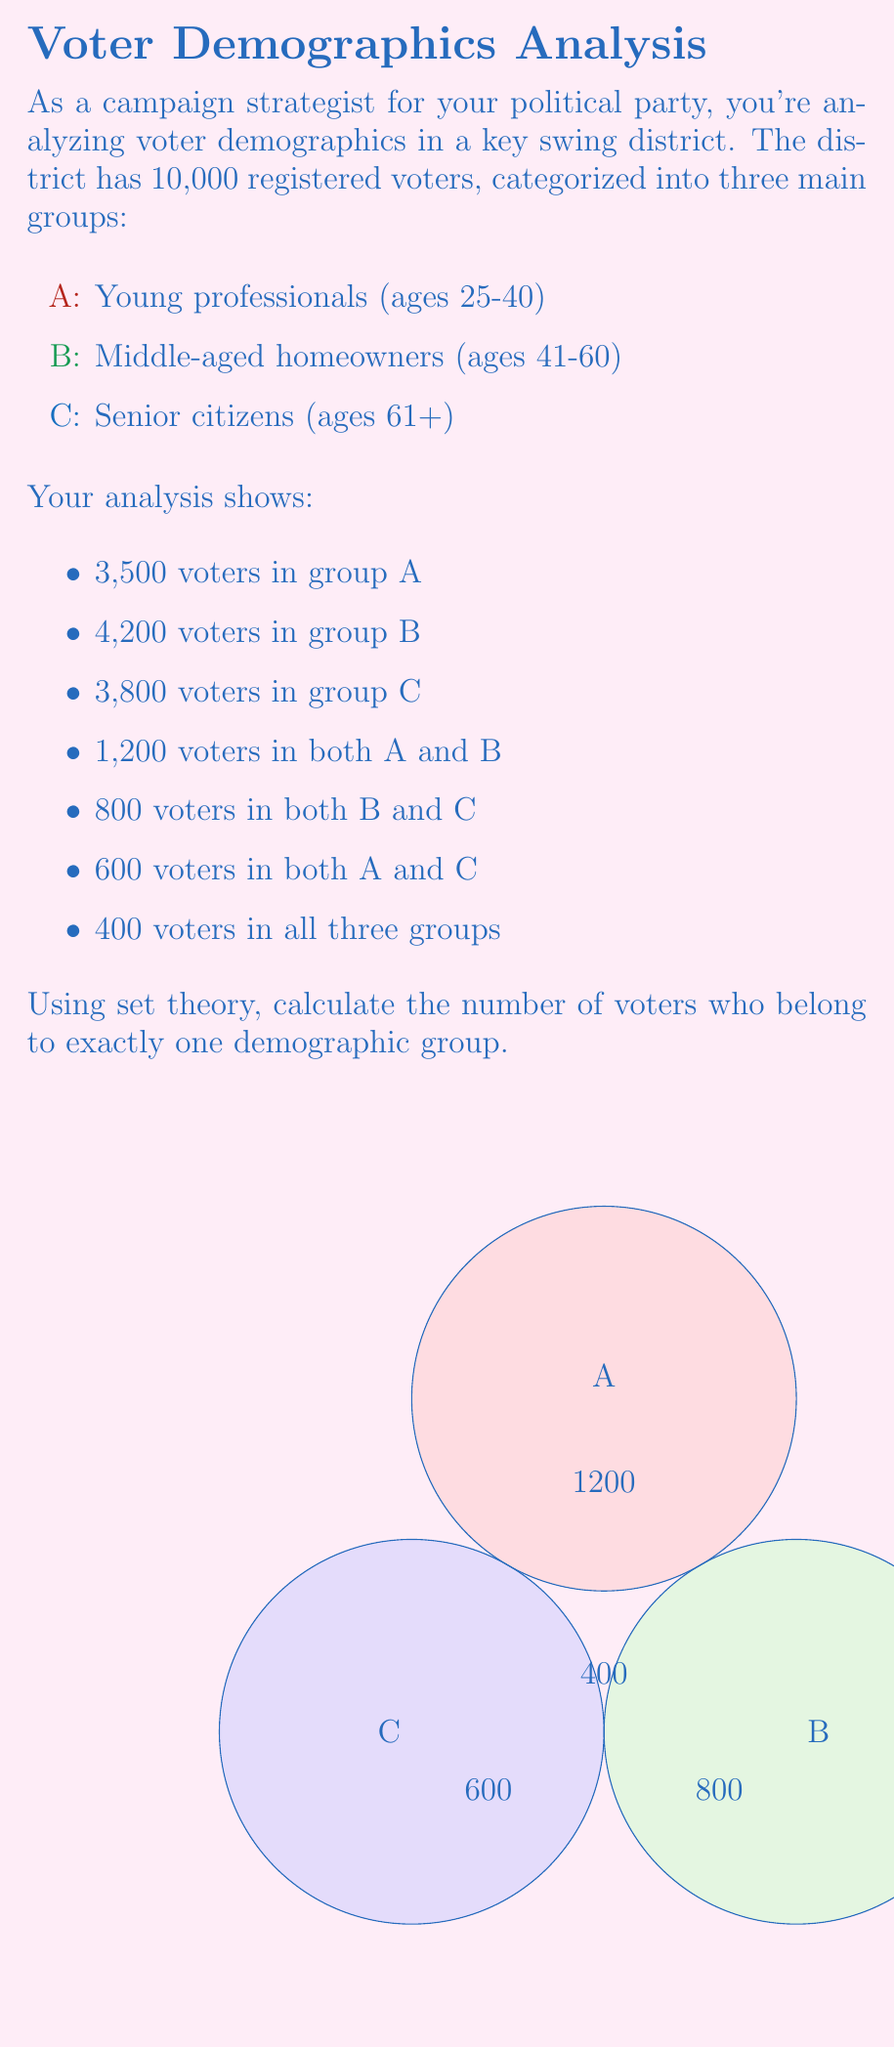Solve this math problem. Let's approach this step-by-step using set theory:

1) First, let's define our universal set U as all registered voters in the district:
   $|U| = 10,000$

2) We're given the following information:
   $|A| = 3,500$
   $|B| = 4,200$
   $|C| = 3,800$
   $|A \cap B| = 1,200$
   $|B \cap C| = 800$
   $|A \cap C| = 600$
   $|A \cap B \cap C| = 400$

3) To find the number of voters in exactly one group, we need to calculate:
   $|A \text{ only}| + |B \text{ only}| + |C \text{ only}|$

4) We can use the inclusion-exclusion principle:
   $|A \cup B \cup C| = |A| + |B| + |C| - |A \cap B| - |B \cap C| - |A \cap C| + |A \cap B \cap C|$

5) Substituting the values:
   $|A \cup B \cup C| = 3,500 + 4,200 + 3,800 - 1,200 - 800 - 600 + 400 = 9,300$

6) The number of voters in at least one group is 9,300. Therefore, the number of voters not in any group is:
   $10,000 - 9,300 = 700$

7) Now, to find those in exactly one group, we subtract those in two or more groups from the total in at least one group:
   $|A \text{ only}| + |B \text{ only}| + |C \text{ only}| = 9,300 - (1,200 + 800 + 600 - 400)$
   $= 9,300 - 2,200 = 7,100$

Therefore, 7,100 voters belong to exactly one demographic group.
Answer: 7,100 voters 